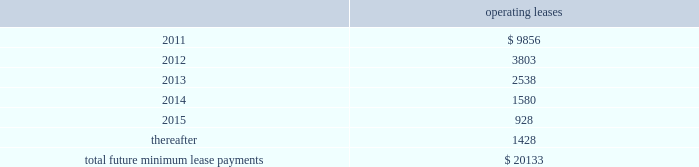Notes to consolidated financial statements 2014 ( continued ) note 14 2014commitments and contingencies leases we conduct a major part of our operations using leased facilities and equipment .
Many of these leases have renewal and purchase options and provide that we pay the cost of property taxes , insurance and maintenance .
Rent expense on all operating leases for fiscal 2010 , 2009 and 2008 was $ 32.8 million , $ 30.2 million , and $ 30.4 million , respectively .
Future minimum lease payments for all noncancelable leases at may 31 , 2010 were as follows : operating leases .
We are party to a number of claims and lawsuits incidental to our business .
In the opinion of management , the reasonably possible outcome of such matters , individually or in the aggregate , will not have a material adverse impact on our financial position , liquidity or results of operations .
We define operating taxes as tax contingencies that are unrelated to income taxes , such as sales and property taxes .
During the course of operations , we must interpret the meaning of various operating tax matters in the united states and in the foreign jurisdictions in which we do business .
Taxing authorities in those various jurisdictions may arrive at different interpretations of applicable tax laws and regulations as they relate to such operating tax matters , which could result in the payment of additional taxes in those jurisdictions .
As of may 31 , 2010 and 2009 we did not have a liability for operating tax items .
The amount of the liability is based on management 2019s best estimate given our history with similar matters and interpretations of current laws and regulations .
Bin/ica agreements in connection with our acquisition of merchant credit card operations of banks , we have entered into sponsorship or depository and processing agreements with certain of the banks .
These agreements allow us to use the banks 2019 identification numbers , referred to as bank identification number for visa transactions and interbank card association number for mastercard transactions , to clear credit card transactions through visa and mastercard .
Certain of such agreements contain financial covenants , and we were in compliance with all such covenants as of may 31 , 2010 .
On june 18 , 2010 , cibc provided notice that it will not renew its sponsorship with us for visa in canada after the initial ten year term .
As a result , their canadian visa sponsorship will expire in march 2011 .
We are .
At december 2010 what was the percent of the total future minimum lease payments for all noncancelable leases that was due in 2012? 
Computations: (9856 / 20133)
Answer: 0.48954. 